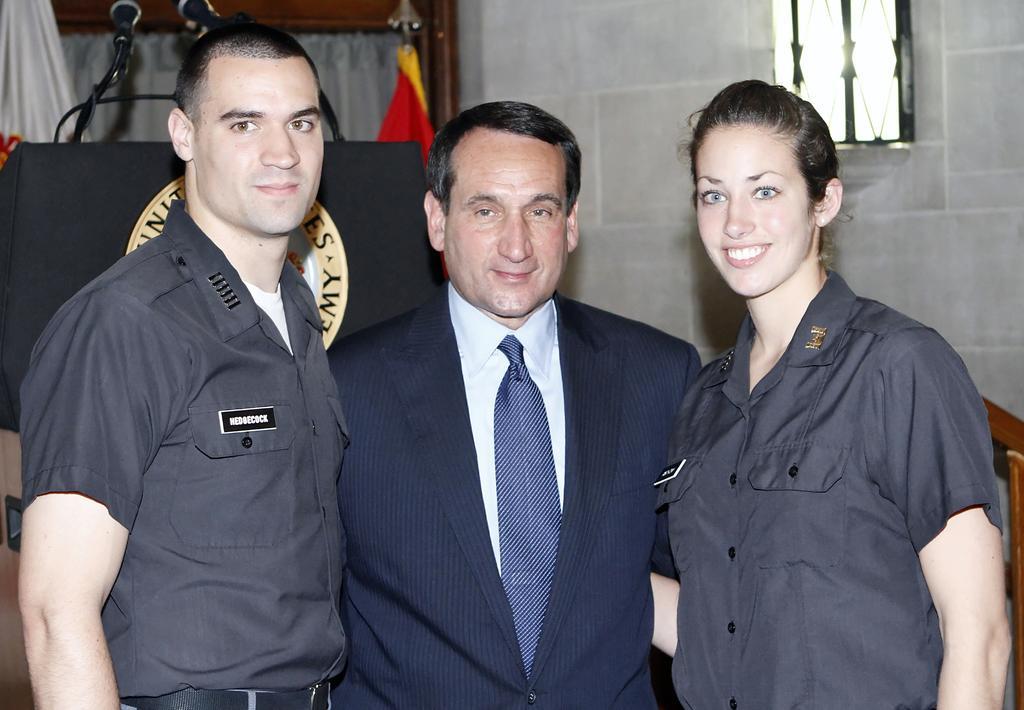In one or two sentences, can you explain what this image depicts? In this image there are three people standing with a smile on their face, behind them there is a wooden staircase fence, a podium with mic´s, behind the podium there are flags, in the background of the image there is a metal grill window on the wall. 